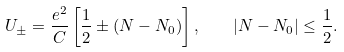Convert formula to latex. <formula><loc_0><loc_0><loc_500><loc_500>U _ { \pm } = \frac { e ^ { 2 } } { C } \left [ \frac { 1 } { 2 } \pm ( N - N _ { 0 } ) \right ] , \quad | N - N _ { 0 } | \leq \frac { 1 } { 2 } .</formula> 